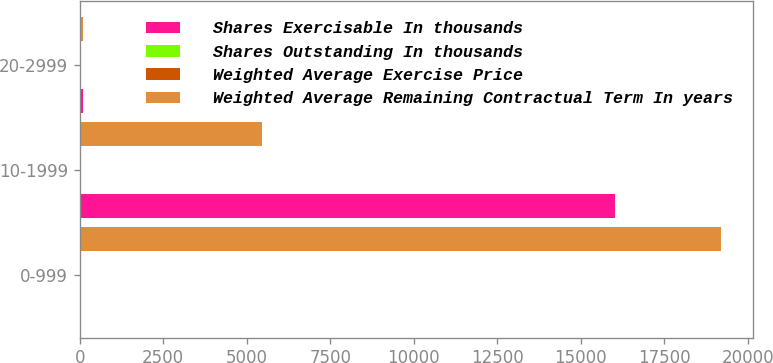<chart> <loc_0><loc_0><loc_500><loc_500><stacked_bar_chart><ecel><fcel>0-999<fcel>10-1999<fcel>20-2999<nl><fcel>Shares Exercisable In thousands<fcel>25<fcel>16024<fcel>82<nl><fcel>Shares Outstanding In thousands<fcel>4.4<fcel>5.1<fcel>2.2<nl><fcel>Weighted Average Exercise Price<fcel>8<fcel>13<fcel>25<nl><fcel>Weighted Average Remaining Contractual Term In years<fcel>19198<fcel>5456<fcel>82<nl></chart> 